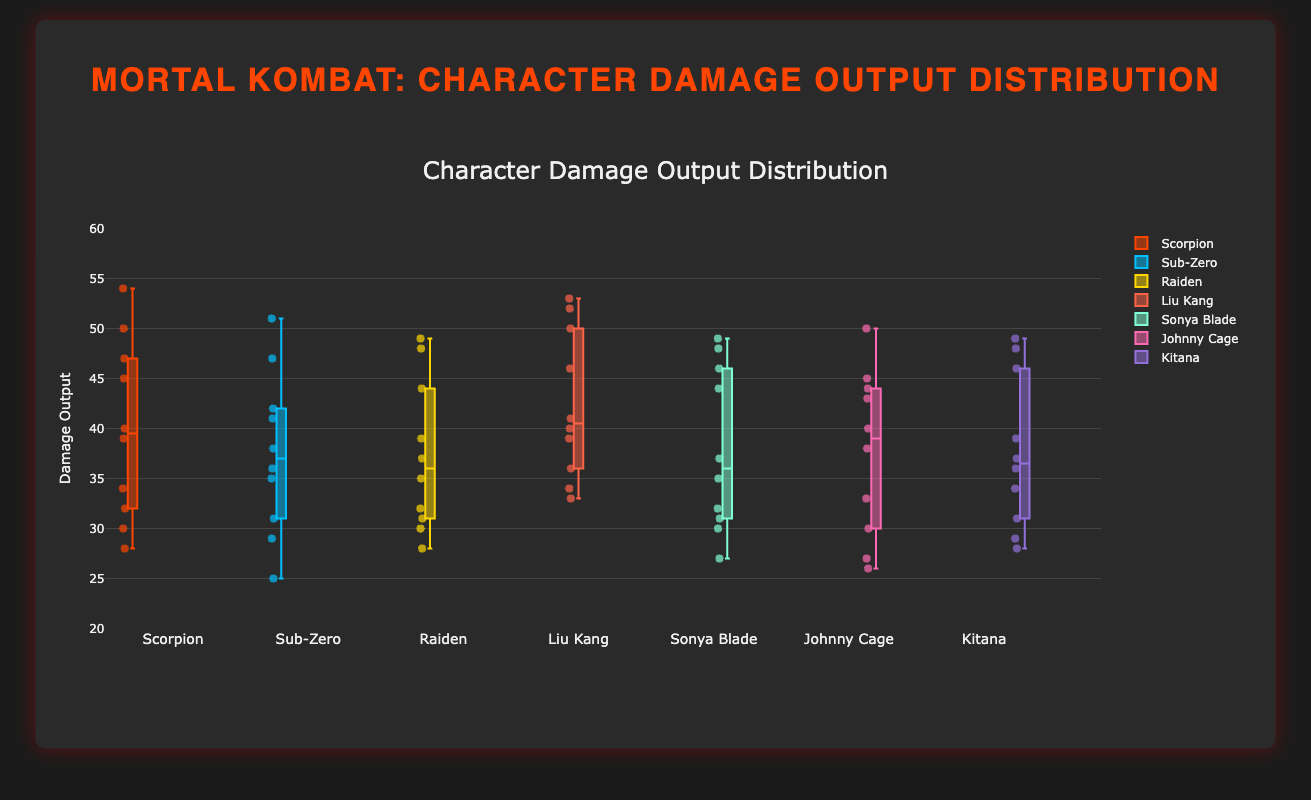**Basic**: What is the title of the figure? The title of the figure is displayed at the top-center and is clearly visible in a larger font size compared to the other text elements.
Answer: Mortal Kombat: Character Damage Output Distribution **Compositional**: What is the median damage output value for Raiden? To find the median, sort Raiden's damage values [30, 35, 49, 28, 48, 39, 37, 44, 32, 31]. After sorting: [28, 30, 31, 32, 35, 37, 39, 44, 48, 49]. The median is the middle value for an even number of elements, so (35+37)/2 = 36.
Answer: 36 **Comparison**: Which character has the highest median damage output? To determine this, we need to calculate and compare the median for each character. Liu Kang has the highest median because it is 41.5, which is higher than all other characters' medians.
Answer: Liu Kang **Chart-Type Specific**: What is the interquartile range (IQR) for Sub-Zero? The IQR is calculated by subtracting the first quartile (Q1) from the third quartile (Q3). For Sub-Zero, Q3 is 42 and Q1 is 29, so the IQR is 42 - 29.
Answer: 13 **Compositional**: What is the range of damage outputs for Johnny Cage? The range is the difference between the highest and lowest values in the data set for Johnny Cage. The highest is 50, and the lowest is 26, so the range is 50 - 26.
Answer: 24 **Comparison**: Which characters have an outlier in their damage output data? Outliers are points that fall outside 1.5*IQR above Q3 or below Q1. Scorpion's 54, Kitana's 49, and Liu Kang's 52 are outliers since they fall outside their respective interquartile ranges.
Answer: Scorpion, Kitana, and Liu Kang **Basic**: What color is used for Sonya Blade's data points? The visual color for Sonya Blade's data points appears as a unique and distinguishable shade that is different from the other characters.
Answer: Aquamarine (approximated as '#7fffd4') **Chart-Type Specific**: Which character has the most evenly distributed damage output values? We look for the character whose box plot is most symmetrical with the smallest IQR. Johnny Cage has a relatively symmetrical box plot with smaller whiskers, indicating an even distribution.
Answer: Johnny Cage **Comparison**: How does Scorpion's median damage output compare to Liu Kang's? By examining the box plots, we observe that Scorpion's median is lower than Liu Kang's. Scorpion's median is around 40, while Liu Kang's is 41.5.
Answer: Scorpion's median is lower than Liu Kang's **Chart-Type Specific**: What can you infer about the skewness of Raiden's data distribution? Raiden's box plot shows a longer whisker above the median indicating a positive skew.
Answer: Positively skewed 